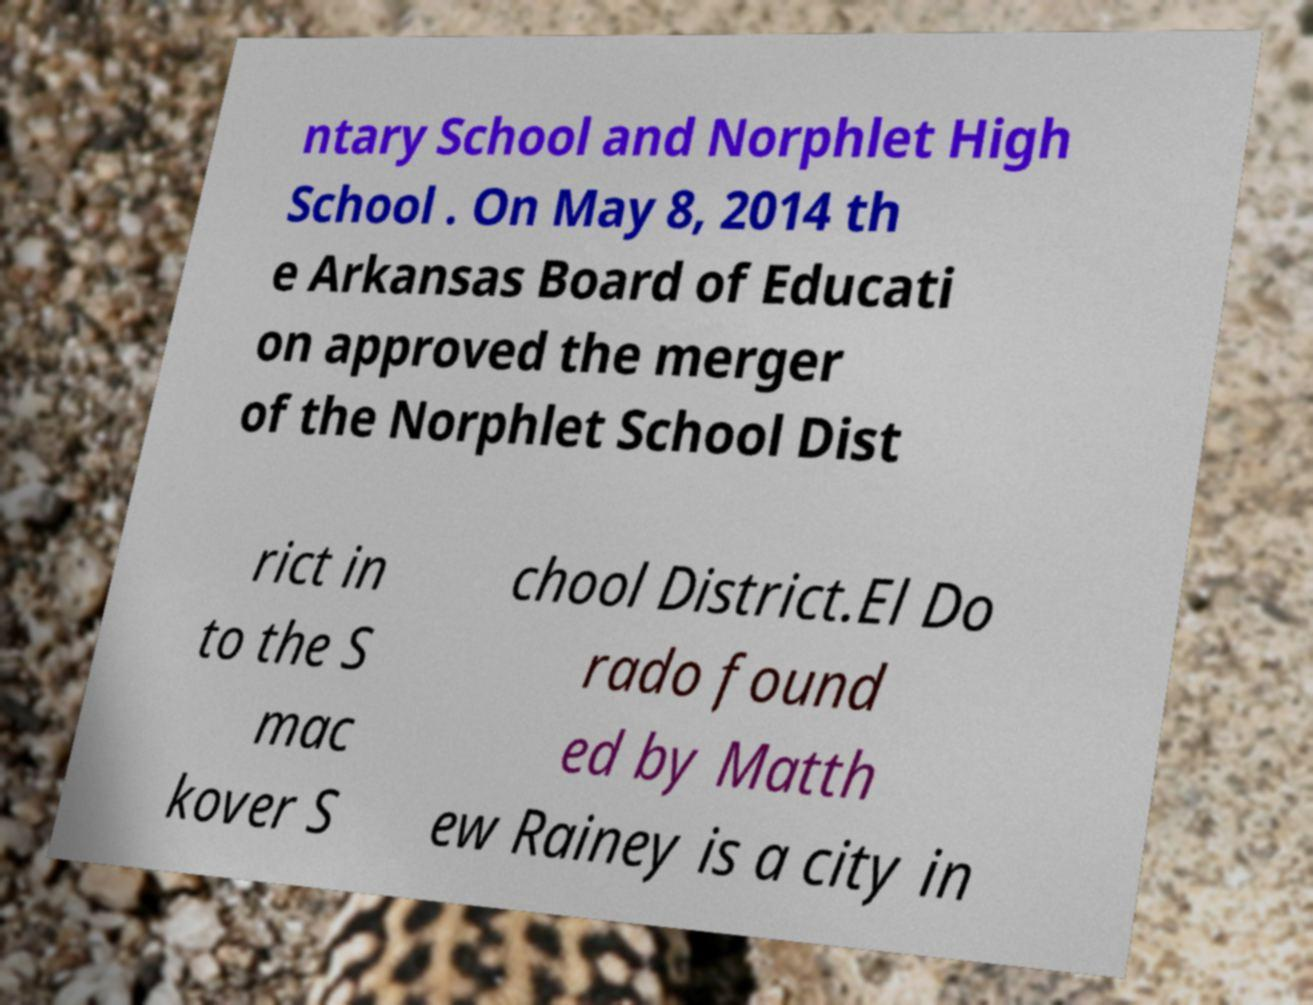Can you read and provide the text displayed in the image?This photo seems to have some interesting text. Can you extract and type it out for me? ntary School and Norphlet High School . On May 8, 2014 th e Arkansas Board of Educati on approved the merger of the Norphlet School Dist rict in to the S mac kover S chool District.El Do rado found ed by Matth ew Rainey is a city in 